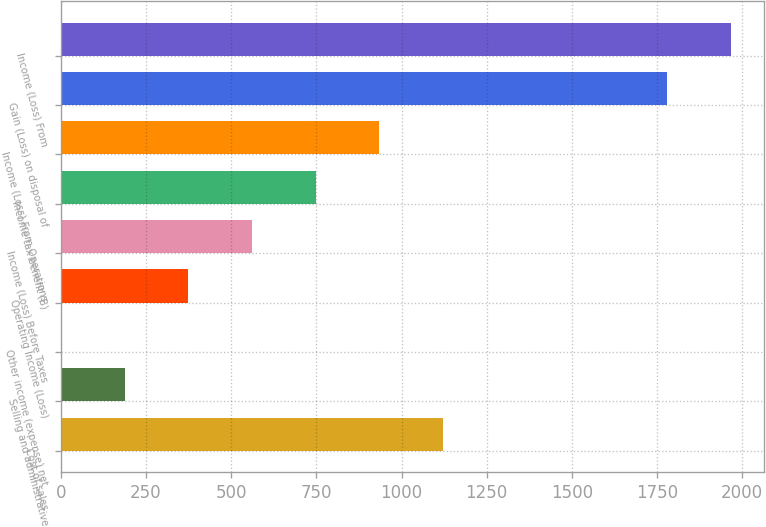<chart> <loc_0><loc_0><loc_500><loc_500><bar_chart><fcel>Cost of sales<fcel>Selling and administrative<fcel>Other income (expense) net<fcel>Operating Income (Loss)<fcel>Income (Loss) Before Taxes<fcel>Income tax benefit (B)<fcel>Income (Loss) From Operations<fcel>Gain (Loss) on disposal of<fcel>Income (Loss) From<nl><fcel>1120.28<fcel>188.13<fcel>1.7<fcel>374.56<fcel>560.99<fcel>747.42<fcel>933.85<fcel>1780.5<fcel>1966.93<nl></chart> 